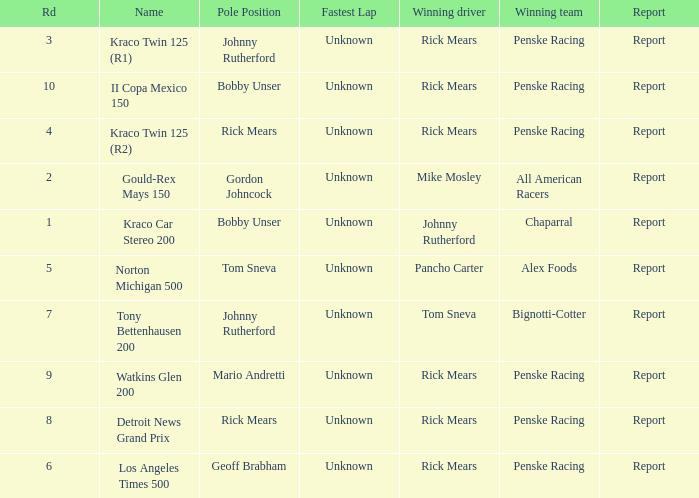How many winning drivers in the kraco twin 125 (r2) race were there? 1.0. 